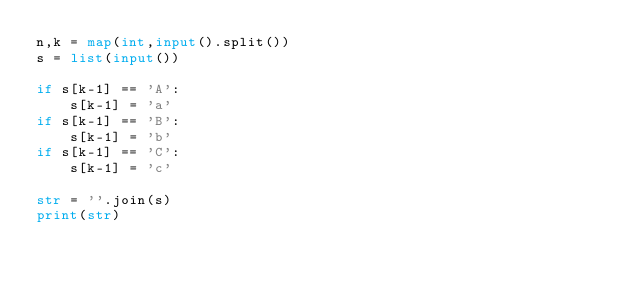Convert code to text. <code><loc_0><loc_0><loc_500><loc_500><_Python_>n,k = map(int,input().split())
s = list(input())

if s[k-1] == 'A':
    s[k-1] = 'a'
if s[k-1] == 'B':
    s[k-1] = 'b'
if s[k-1] == 'C':
    s[k-1] = 'c'

str = ''.join(s)
print(str)</code> 